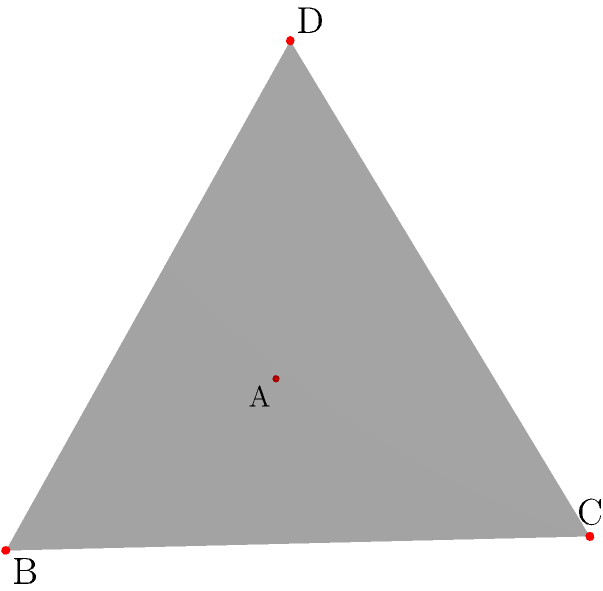In a regular tetrahedron ABCD, where all faces are congruent equilateral triangles, what is the angle between any two adjacent faces? Provide your answer in degrees, rounded to the nearest whole number. To find the angle between two adjacent faces of a regular tetrahedron, we can follow these steps:

1) In a regular tetrahedron, all faces are congruent equilateral triangles, and all dihedral angles (angles between faces) are equal.

2) The sum of the angles around any vertex of a tetrahedron is less than 360°. In fact, it's exactly 3 times the dihedral angle.

3) Let θ be the dihedral angle. Then:

   $$3θ = 360° - ε$$

   where ε is the defect at each vertex.

4) The defect at each vertex is related to the solid angle Ω at the vertex:

   $$Ω = ε × \frac{π}{180°}$$

5) For a regular tetrahedron, the solid angle at each vertex is:

   $$Ω = \arccos\left(\frac{23}{27}\right) \approx 0.551287$$

6) Converting this to degrees:

   $$ε = Ω × \frac{180°}{π} \approx 31.5862°$$

7) Substituting this into the equation from step 3:

   $$3θ = 360° - 31.5862°$$
   $$3θ = 328.4138°$$
   $$θ = 109.4713°$$

8) Rounding to the nearest whole number:

   $$θ ≈ 109°$$

Therefore, the angle between any two adjacent faces of a regular tetrahedron is approximately 109°.
Answer: 109° 